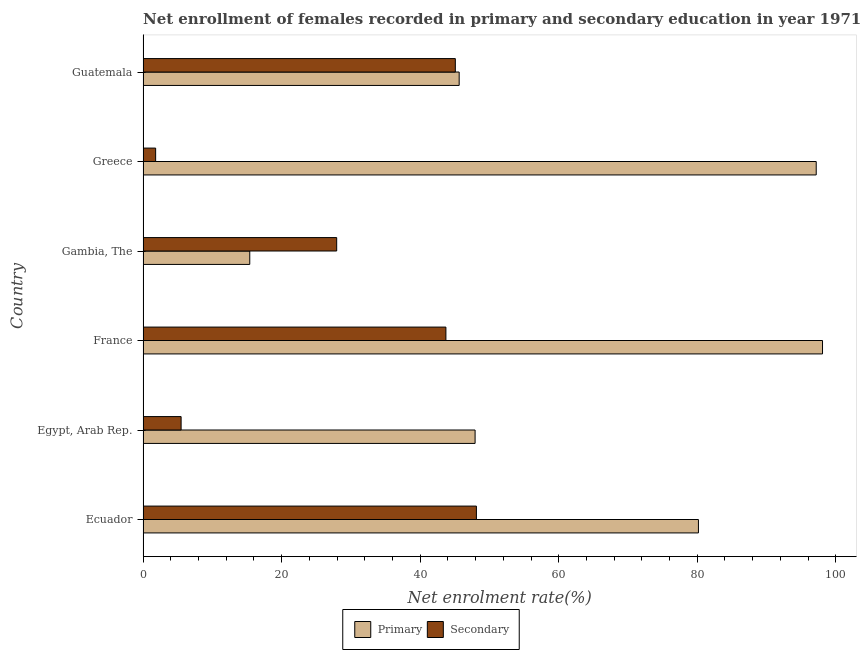How many different coloured bars are there?
Keep it short and to the point. 2. Are the number of bars per tick equal to the number of legend labels?
Offer a terse response. Yes. What is the label of the 1st group of bars from the top?
Keep it short and to the point. Guatemala. What is the enrollment rate in secondary education in Guatemala?
Make the answer very short. 45.08. Across all countries, what is the maximum enrollment rate in primary education?
Provide a short and direct response. 98.08. Across all countries, what is the minimum enrollment rate in primary education?
Keep it short and to the point. 15.4. In which country was the enrollment rate in secondary education maximum?
Provide a short and direct response. Ecuador. What is the total enrollment rate in secondary education in the graph?
Your response must be concise. 172.18. What is the difference between the enrollment rate in secondary education in Greece and that in Guatemala?
Your response must be concise. -43.26. What is the difference between the enrollment rate in secondary education in Guatemala and the enrollment rate in primary education in Ecuador?
Make the answer very short. -35.09. What is the average enrollment rate in secondary education per country?
Offer a very short reply. 28.7. What is the difference between the enrollment rate in secondary education and enrollment rate in primary education in Egypt, Arab Rep.?
Ensure brevity in your answer.  -42.44. What is the ratio of the enrollment rate in primary education in Gambia, The to that in Greece?
Make the answer very short. 0.16. What is the difference between the highest and the second highest enrollment rate in secondary education?
Give a very brief answer. 3.04. What is the difference between the highest and the lowest enrollment rate in primary education?
Give a very brief answer. 82.68. Is the sum of the enrollment rate in primary education in Ecuador and Guatemala greater than the maximum enrollment rate in secondary education across all countries?
Your response must be concise. Yes. What does the 2nd bar from the top in Egypt, Arab Rep. represents?
Give a very brief answer. Primary. What does the 1st bar from the bottom in Gambia, The represents?
Offer a very short reply. Primary. How many bars are there?
Your answer should be very brief. 12. Does the graph contain any zero values?
Provide a succinct answer. No. Does the graph contain grids?
Provide a succinct answer. No. What is the title of the graph?
Ensure brevity in your answer.  Net enrollment of females recorded in primary and secondary education in year 1971. Does "Methane emissions" appear as one of the legend labels in the graph?
Your response must be concise. No. What is the label or title of the X-axis?
Make the answer very short. Net enrolment rate(%). What is the label or title of the Y-axis?
Ensure brevity in your answer.  Country. What is the Net enrolment rate(%) in Primary in Ecuador?
Offer a terse response. 80.17. What is the Net enrolment rate(%) in Secondary in Ecuador?
Keep it short and to the point. 48.12. What is the Net enrolment rate(%) in Primary in Egypt, Arab Rep.?
Your answer should be compact. 47.93. What is the Net enrolment rate(%) of Secondary in Egypt, Arab Rep.?
Your response must be concise. 5.49. What is the Net enrolment rate(%) in Primary in France?
Ensure brevity in your answer.  98.08. What is the Net enrolment rate(%) in Secondary in France?
Keep it short and to the point. 43.72. What is the Net enrolment rate(%) of Primary in Gambia, The?
Provide a succinct answer. 15.4. What is the Net enrolment rate(%) of Secondary in Gambia, The?
Give a very brief answer. 27.95. What is the Net enrolment rate(%) of Primary in Greece?
Give a very brief answer. 97.17. What is the Net enrolment rate(%) in Secondary in Greece?
Make the answer very short. 1.82. What is the Net enrolment rate(%) in Primary in Guatemala?
Ensure brevity in your answer.  45.63. What is the Net enrolment rate(%) in Secondary in Guatemala?
Your answer should be very brief. 45.08. Across all countries, what is the maximum Net enrolment rate(%) in Primary?
Provide a succinct answer. 98.08. Across all countries, what is the maximum Net enrolment rate(%) of Secondary?
Offer a very short reply. 48.12. Across all countries, what is the minimum Net enrolment rate(%) in Primary?
Your answer should be very brief. 15.4. Across all countries, what is the minimum Net enrolment rate(%) of Secondary?
Give a very brief answer. 1.82. What is the total Net enrolment rate(%) of Primary in the graph?
Ensure brevity in your answer.  384.39. What is the total Net enrolment rate(%) in Secondary in the graph?
Ensure brevity in your answer.  172.18. What is the difference between the Net enrolment rate(%) in Primary in Ecuador and that in Egypt, Arab Rep.?
Offer a very short reply. 32.24. What is the difference between the Net enrolment rate(%) of Secondary in Ecuador and that in Egypt, Arab Rep.?
Your answer should be compact. 42.63. What is the difference between the Net enrolment rate(%) in Primary in Ecuador and that in France?
Your answer should be very brief. -17.91. What is the difference between the Net enrolment rate(%) of Secondary in Ecuador and that in France?
Offer a terse response. 4.4. What is the difference between the Net enrolment rate(%) of Primary in Ecuador and that in Gambia, The?
Your response must be concise. 64.77. What is the difference between the Net enrolment rate(%) of Secondary in Ecuador and that in Gambia, The?
Ensure brevity in your answer.  20.17. What is the difference between the Net enrolment rate(%) in Primary in Ecuador and that in Greece?
Offer a very short reply. -17. What is the difference between the Net enrolment rate(%) of Secondary in Ecuador and that in Greece?
Keep it short and to the point. 46.3. What is the difference between the Net enrolment rate(%) in Primary in Ecuador and that in Guatemala?
Your answer should be very brief. 34.54. What is the difference between the Net enrolment rate(%) of Secondary in Ecuador and that in Guatemala?
Ensure brevity in your answer.  3.04. What is the difference between the Net enrolment rate(%) of Primary in Egypt, Arab Rep. and that in France?
Ensure brevity in your answer.  -50.15. What is the difference between the Net enrolment rate(%) in Secondary in Egypt, Arab Rep. and that in France?
Your answer should be very brief. -38.22. What is the difference between the Net enrolment rate(%) of Primary in Egypt, Arab Rep. and that in Gambia, The?
Your response must be concise. 32.53. What is the difference between the Net enrolment rate(%) in Secondary in Egypt, Arab Rep. and that in Gambia, The?
Make the answer very short. -22.46. What is the difference between the Net enrolment rate(%) of Primary in Egypt, Arab Rep. and that in Greece?
Offer a terse response. -49.24. What is the difference between the Net enrolment rate(%) of Secondary in Egypt, Arab Rep. and that in Greece?
Offer a terse response. 3.68. What is the difference between the Net enrolment rate(%) of Primary in Egypt, Arab Rep. and that in Guatemala?
Your answer should be compact. 2.3. What is the difference between the Net enrolment rate(%) of Secondary in Egypt, Arab Rep. and that in Guatemala?
Offer a very short reply. -39.58. What is the difference between the Net enrolment rate(%) of Primary in France and that in Gambia, The?
Your response must be concise. 82.68. What is the difference between the Net enrolment rate(%) in Secondary in France and that in Gambia, The?
Keep it short and to the point. 15.77. What is the difference between the Net enrolment rate(%) of Primary in France and that in Greece?
Provide a succinct answer. 0.91. What is the difference between the Net enrolment rate(%) in Secondary in France and that in Greece?
Your response must be concise. 41.9. What is the difference between the Net enrolment rate(%) of Primary in France and that in Guatemala?
Ensure brevity in your answer.  52.45. What is the difference between the Net enrolment rate(%) in Secondary in France and that in Guatemala?
Make the answer very short. -1.36. What is the difference between the Net enrolment rate(%) of Primary in Gambia, The and that in Greece?
Provide a succinct answer. -81.77. What is the difference between the Net enrolment rate(%) of Secondary in Gambia, The and that in Greece?
Offer a very short reply. 26.14. What is the difference between the Net enrolment rate(%) in Primary in Gambia, The and that in Guatemala?
Your answer should be compact. -30.23. What is the difference between the Net enrolment rate(%) of Secondary in Gambia, The and that in Guatemala?
Offer a terse response. -17.13. What is the difference between the Net enrolment rate(%) of Primary in Greece and that in Guatemala?
Your answer should be compact. 51.54. What is the difference between the Net enrolment rate(%) in Secondary in Greece and that in Guatemala?
Give a very brief answer. -43.26. What is the difference between the Net enrolment rate(%) in Primary in Ecuador and the Net enrolment rate(%) in Secondary in Egypt, Arab Rep.?
Keep it short and to the point. 74.68. What is the difference between the Net enrolment rate(%) of Primary in Ecuador and the Net enrolment rate(%) of Secondary in France?
Make the answer very short. 36.45. What is the difference between the Net enrolment rate(%) of Primary in Ecuador and the Net enrolment rate(%) of Secondary in Gambia, The?
Offer a terse response. 52.22. What is the difference between the Net enrolment rate(%) in Primary in Ecuador and the Net enrolment rate(%) in Secondary in Greece?
Your response must be concise. 78.36. What is the difference between the Net enrolment rate(%) in Primary in Ecuador and the Net enrolment rate(%) in Secondary in Guatemala?
Your response must be concise. 35.09. What is the difference between the Net enrolment rate(%) in Primary in Egypt, Arab Rep. and the Net enrolment rate(%) in Secondary in France?
Give a very brief answer. 4.21. What is the difference between the Net enrolment rate(%) of Primary in Egypt, Arab Rep. and the Net enrolment rate(%) of Secondary in Gambia, The?
Make the answer very short. 19.98. What is the difference between the Net enrolment rate(%) of Primary in Egypt, Arab Rep. and the Net enrolment rate(%) of Secondary in Greece?
Ensure brevity in your answer.  46.12. What is the difference between the Net enrolment rate(%) in Primary in Egypt, Arab Rep. and the Net enrolment rate(%) in Secondary in Guatemala?
Make the answer very short. 2.85. What is the difference between the Net enrolment rate(%) in Primary in France and the Net enrolment rate(%) in Secondary in Gambia, The?
Provide a succinct answer. 70.13. What is the difference between the Net enrolment rate(%) in Primary in France and the Net enrolment rate(%) in Secondary in Greece?
Make the answer very short. 96.27. What is the difference between the Net enrolment rate(%) in Primary in France and the Net enrolment rate(%) in Secondary in Guatemala?
Make the answer very short. 53.01. What is the difference between the Net enrolment rate(%) in Primary in Gambia, The and the Net enrolment rate(%) in Secondary in Greece?
Keep it short and to the point. 13.59. What is the difference between the Net enrolment rate(%) in Primary in Gambia, The and the Net enrolment rate(%) in Secondary in Guatemala?
Make the answer very short. -29.67. What is the difference between the Net enrolment rate(%) in Primary in Greece and the Net enrolment rate(%) in Secondary in Guatemala?
Keep it short and to the point. 52.1. What is the average Net enrolment rate(%) of Primary per country?
Keep it short and to the point. 64.07. What is the average Net enrolment rate(%) of Secondary per country?
Provide a succinct answer. 28.7. What is the difference between the Net enrolment rate(%) in Primary and Net enrolment rate(%) in Secondary in Ecuador?
Offer a very short reply. 32.05. What is the difference between the Net enrolment rate(%) of Primary and Net enrolment rate(%) of Secondary in Egypt, Arab Rep.?
Give a very brief answer. 42.44. What is the difference between the Net enrolment rate(%) in Primary and Net enrolment rate(%) in Secondary in France?
Your answer should be compact. 54.37. What is the difference between the Net enrolment rate(%) of Primary and Net enrolment rate(%) of Secondary in Gambia, The?
Make the answer very short. -12.55. What is the difference between the Net enrolment rate(%) in Primary and Net enrolment rate(%) in Secondary in Greece?
Your response must be concise. 95.36. What is the difference between the Net enrolment rate(%) of Primary and Net enrolment rate(%) of Secondary in Guatemala?
Provide a short and direct response. 0.55. What is the ratio of the Net enrolment rate(%) in Primary in Ecuador to that in Egypt, Arab Rep.?
Offer a very short reply. 1.67. What is the ratio of the Net enrolment rate(%) of Secondary in Ecuador to that in Egypt, Arab Rep.?
Provide a short and direct response. 8.76. What is the ratio of the Net enrolment rate(%) of Primary in Ecuador to that in France?
Your response must be concise. 0.82. What is the ratio of the Net enrolment rate(%) in Secondary in Ecuador to that in France?
Offer a terse response. 1.1. What is the ratio of the Net enrolment rate(%) of Primary in Ecuador to that in Gambia, The?
Your response must be concise. 5.21. What is the ratio of the Net enrolment rate(%) in Secondary in Ecuador to that in Gambia, The?
Make the answer very short. 1.72. What is the ratio of the Net enrolment rate(%) in Primary in Ecuador to that in Greece?
Make the answer very short. 0.82. What is the ratio of the Net enrolment rate(%) of Secondary in Ecuador to that in Greece?
Ensure brevity in your answer.  26.5. What is the ratio of the Net enrolment rate(%) of Primary in Ecuador to that in Guatemala?
Provide a short and direct response. 1.76. What is the ratio of the Net enrolment rate(%) in Secondary in Ecuador to that in Guatemala?
Provide a short and direct response. 1.07. What is the ratio of the Net enrolment rate(%) of Primary in Egypt, Arab Rep. to that in France?
Provide a succinct answer. 0.49. What is the ratio of the Net enrolment rate(%) of Secondary in Egypt, Arab Rep. to that in France?
Keep it short and to the point. 0.13. What is the ratio of the Net enrolment rate(%) in Primary in Egypt, Arab Rep. to that in Gambia, The?
Offer a very short reply. 3.11. What is the ratio of the Net enrolment rate(%) in Secondary in Egypt, Arab Rep. to that in Gambia, The?
Provide a short and direct response. 0.2. What is the ratio of the Net enrolment rate(%) in Primary in Egypt, Arab Rep. to that in Greece?
Ensure brevity in your answer.  0.49. What is the ratio of the Net enrolment rate(%) in Secondary in Egypt, Arab Rep. to that in Greece?
Your answer should be very brief. 3.03. What is the ratio of the Net enrolment rate(%) in Primary in Egypt, Arab Rep. to that in Guatemala?
Your answer should be very brief. 1.05. What is the ratio of the Net enrolment rate(%) in Secondary in Egypt, Arab Rep. to that in Guatemala?
Give a very brief answer. 0.12. What is the ratio of the Net enrolment rate(%) in Primary in France to that in Gambia, The?
Make the answer very short. 6.37. What is the ratio of the Net enrolment rate(%) in Secondary in France to that in Gambia, The?
Your response must be concise. 1.56. What is the ratio of the Net enrolment rate(%) in Primary in France to that in Greece?
Your answer should be compact. 1.01. What is the ratio of the Net enrolment rate(%) in Secondary in France to that in Greece?
Your response must be concise. 24.08. What is the ratio of the Net enrolment rate(%) of Primary in France to that in Guatemala?
Your answer should be compact. 2.15. What is the ratio of the Net enrolment rate(%) in Secondary in France to that in Guatemala?
Provide a succinct answer. 0.97. What is the ratio of the Net enrolment rate(%) of Primary in Gambia, The to that in Greece?
Your answer should be compact. 0.16. What is the ratio of the Net enrolment rate(%) of Secondary in Gambia, The to that in Greece?
Make the answer very short. 15.4. What is the ratio of the Net enrolment rate(%) of Primary in Gambia, The to that in Guatemala?
Your response must be concise. 0.34. What is the ratio of the Net enrolment rate(%) of Secondary in Gambia, The to that in Guatemala?
Your answer should be very brief. 0.62. What is the ratio of the Net enrolment rate(%) in Primary in Greece to that in Guatemala?
Keep it short and to the point. 2.13. What is the ratio of the Net enrolment rate(%) in Secondary in Greece to that in Guatemala?
Provide a short and direct response. 0.04. What is the difference between the highest and the second highest Net enrolment rate(%) of Primary?
Ensure brevity in your answer.  0.91. What is the difference between the highest and the second highest Net enrolment rate(%) in Secondary?
Give a very brief answer. 3.04. What is the difference between the highest and the lowest Net enrolment rate(%) of Primary?
Your answer should be compact. 82.68. What is the difference between the highest and the lowest Net enrolment rate(%) in Secondary?
Give a very brief answer. 46.3. 